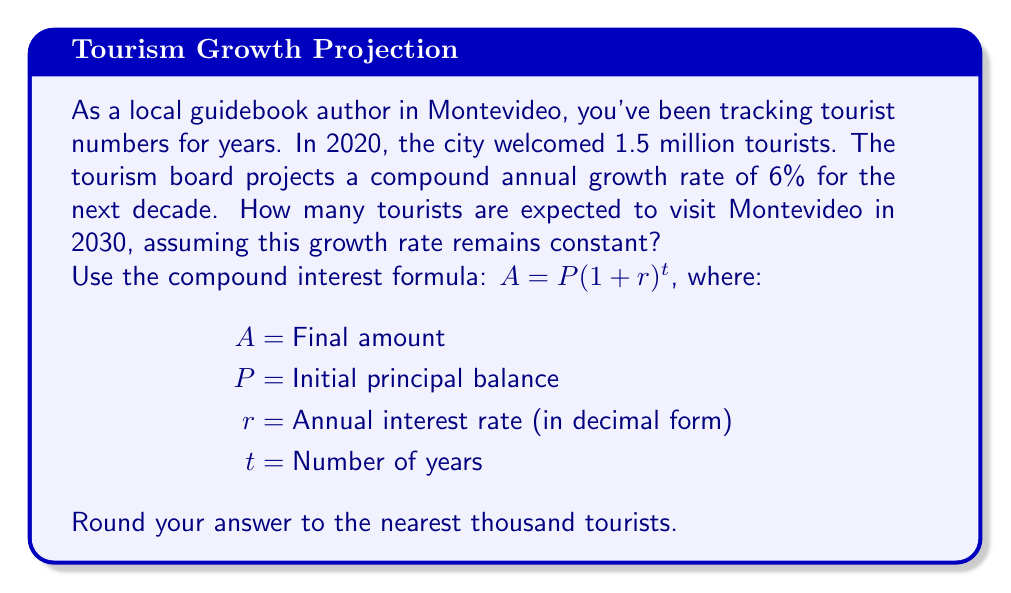Show me your answer to this math problem. To solve this problem, we'll use the compound interest formula:

$$A = P(1 + r)^t$$

Where:
$A$ = Final number of tourists (what we're solving for)
$P$ = Initial number of tourists (1.5 million in 2020)
$r$ = Annual growth rate (6% or 0.06)
$t$ = Number of years (10 years from 2020 to 2030)

Let's plug in the values:

$$A = 1,500,000 \cdot (1 + 0.06)^{10}$$

Now, let's calculate step by step:

1) First, calculate $(1 + 0.06)^{10}$:
   $$(1.06)^{10} \approx 1.7908$$

2) Multiply this by the initial number of tourists:
   $$1,500,000 \cdot 1.7908 \approx 2,686,200$$

3) Rounding to the nearest thousand:
   $$2,686,200 \approx 2,686,000$$

Therefore, approximately 2,686,000 tourists are expected to visit Montevideo in 2030.
Answer: 2,686,000 tourists 